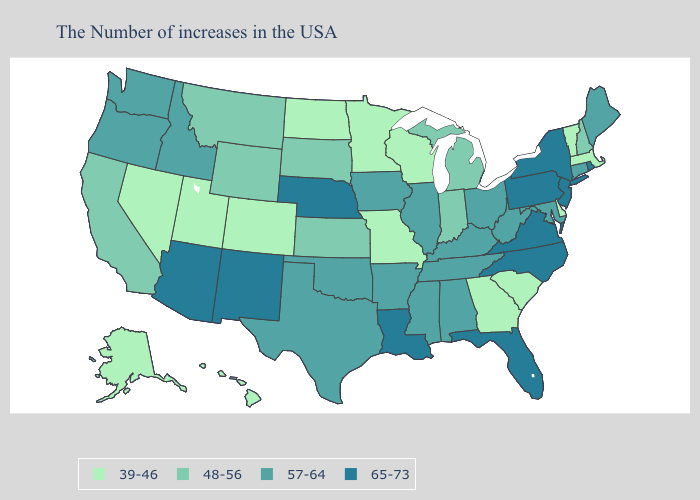Which states have the highest value in the USA?
Be succinct. Rhode Island, New York, New Jersey, Pennsylvania, Virginia, North Carolina, Florida, Louisiana, Nebraska, New Mexico, Arizona. Name the states that have a value in the range 57-64?
Be succinct. Maine, Connecticut, Maryland, West Virginia, Ohio, Kentucky, Alabama, Tennessee, Illinois, Mississippi, Arkansas, Iowa, Oklahoma, Texas, Idaho, Washington, Oregon. What is the lowest value in the West?
Answer briefly. 39-46. What is the value of Florida?
Give a very brief answer. 65-73. Name the states that have a value in the range 48-56?
Concise answer only. New Hampshire, Michigan, Indiana, Kansas, South Dakota, Wyoming, Montana, California. What is the lowest value in states that border Maryland?
Concise answer only. 39-46. Name the states that have a value in the range 65-73?
Give a very brief answer. Rhode Island, New York, New Jersey, Pennsylvania, Virginia, North Carolina, Florida, Louisiana, Nebraska, New Mexico, Arizona. What is the value of Florida?
Concise answer only. 65-73. What is the highest value in states that border Maine?
Give a very brief answer. 48-56. What is the lowest value in the USA?
Short answer required. 39-46. What is the lowest value in states that border California?
Give a very brief answer. 39-46. How many symbols are there in the legend?
Keep it brief. 4. Does South Carolina have the lowest value in the USA?
Write a very short answer. Yes. Name the states that have a value in the range 57-64?
Give a very brief answer. Maine, Connecticut, Maryland, West Virginia, Ohio, Kentucky, Alabama, Tennessee, Illinois, Mississippi, Arkansas, Iowa, Oklahoma, Texas, Idaho, Washington, Oregon. Does the first symbol in the legend represent the smallest category?
Be succinct. Yes. 